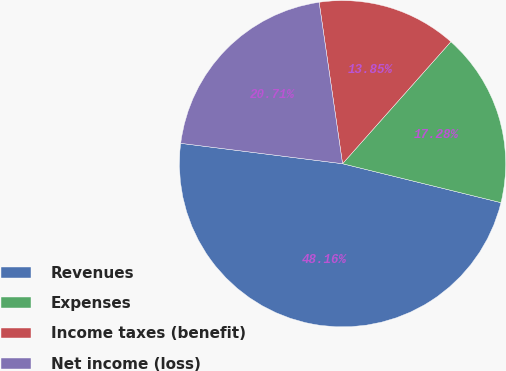Convert chart. <chart><loc_0><loc_0><loc_500><loc_500><pie_chart><fcel>Revenues<fcel>Expenses<fcel>Income taxes (benefit)<fcel>Net income (loss)<nl><fcel>48.16%<fcel>17.28%<fcel>13.85%<fcel>20.71%<nl></chart> 